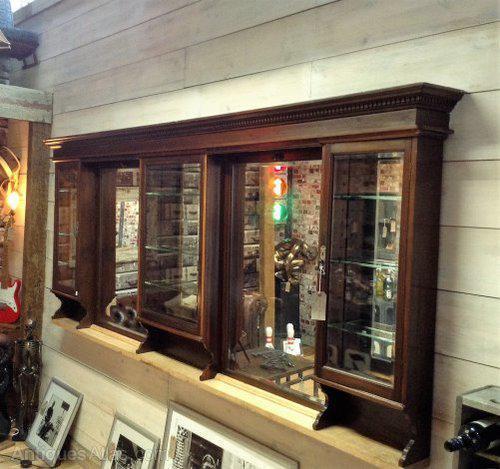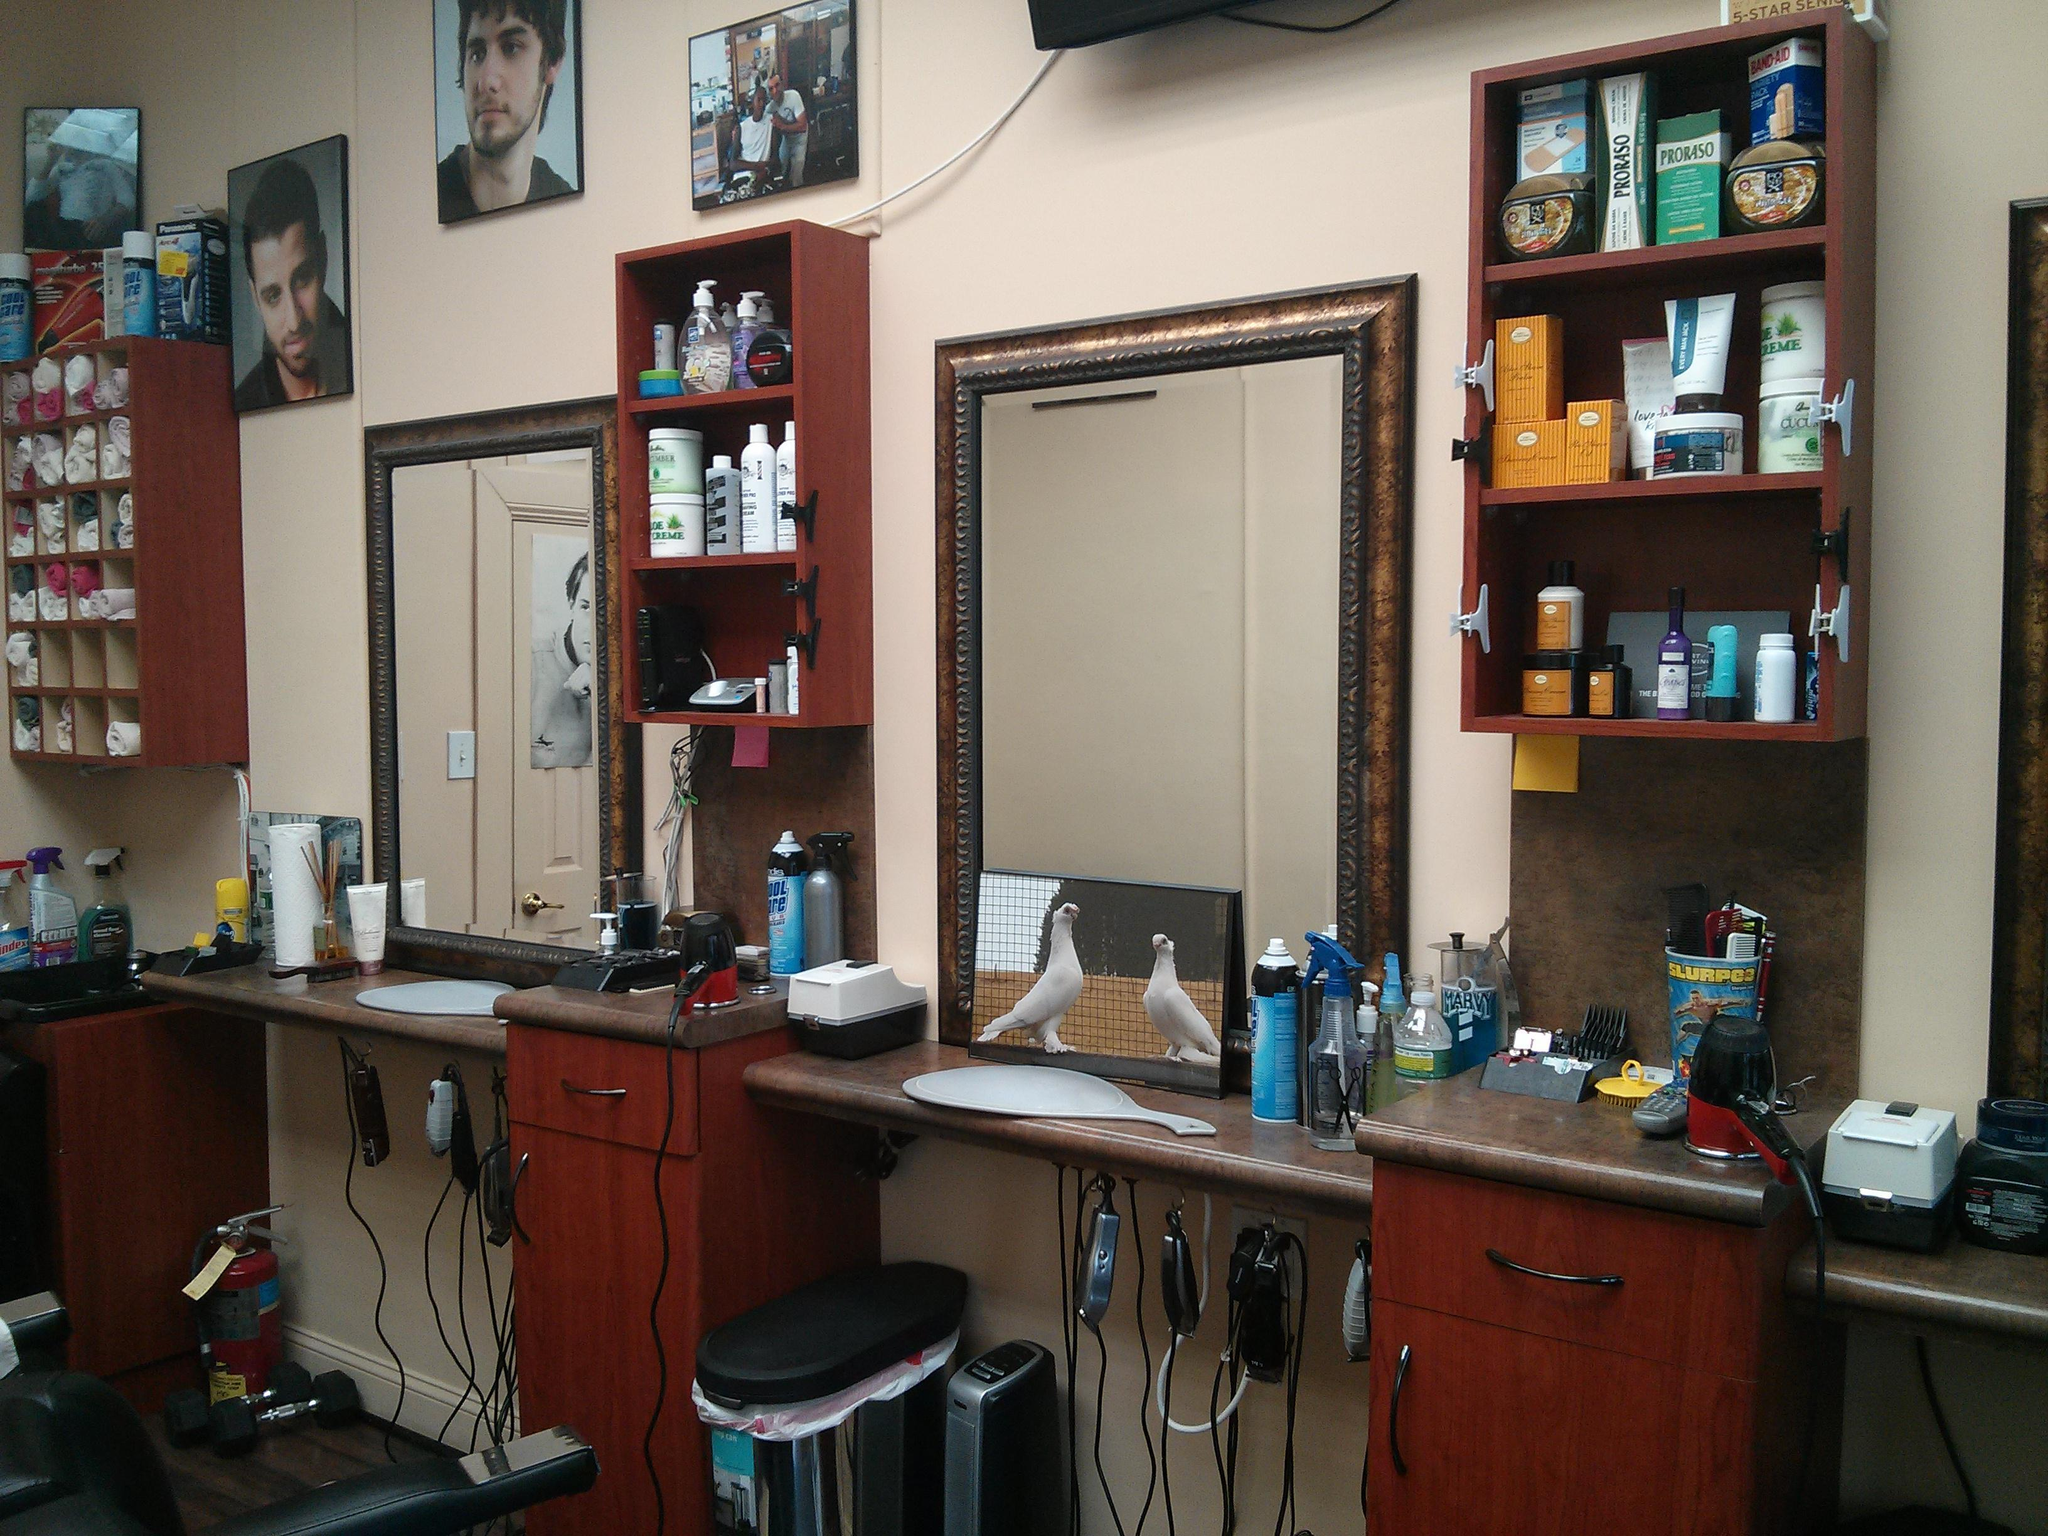The first image is the image on the left, the second image is the image on the right. Considering the images on both sides, is "In at least one image there are three square mirrors." valid? Answer yes or no. No. The first image is the image on the left, the second image is the image on the right. Evaluate the accuracy of this statement regarding the images: "A floor has a checkered pattern.". Is it true? Answer yes or no. No. 